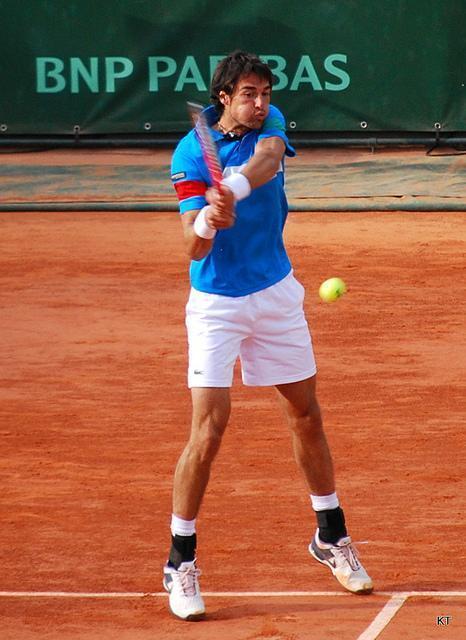How many umbrellas are there?
Give a very brief answer. 0. 